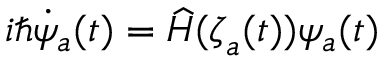Convert formula to latex. <formula><loc_0><loc_0><loc_500><loc_500>i \hbar { \dot } { \psi } _ { a } ( t ) = \widehat { H } ( { \zeta } _ { a } ( t ) ) \psi _ { a } ( t )</formula> 